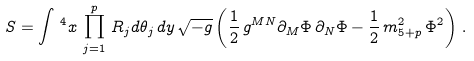<formula> <loc_0><loc_0><loc_500><loc_500>S = \int \, ^ { 4 } x \, \prod _ { j = 1 } ^ { p } \, R _ { j } d \theta _ { j } \, d y \, \sqrt { - g } \left ( \frac { 1 } { 2 } \, g ^ { M N } \partial _ { M } \Phi \, \partial _ { N } \Phi - \frac { 1 } { 2 } \, m _ { 5 + p } ^ { 2 } \, \Phi ^ { 2 } \right ) \, .</formula> 